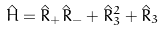<formula> <loc_0><loc_0><loc_500><loc_500>\hat { H } = { \hat { R } } _ { + } { \hat { R } } _ { - } + { \hat { R } } _ { 3 } ^ { 2 } + { \hat { R } } _ { 3 }</formula> 